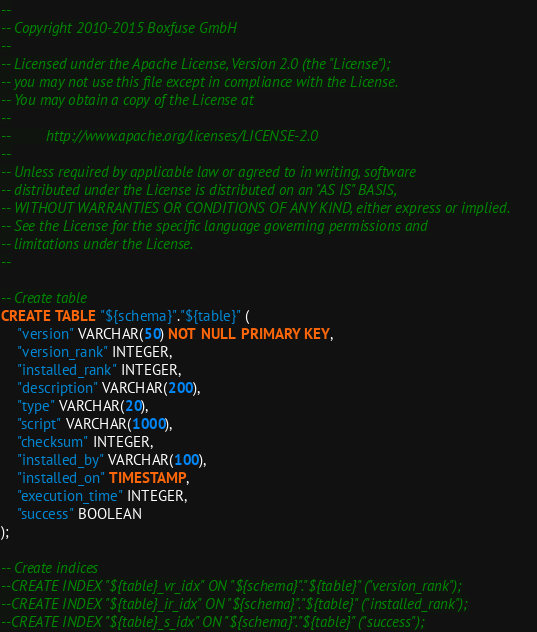<code> <loc_0><loc_0><loc_500><loc_500><_SQL_>--
-- Copyright 2010-2015 Boxfuse GmbH
--
-- Licensed under the Apache License, Version 2.0 (the "License");
-- you may not use this file except in compliance with the License.
-- You may obtain a copy of the License at
--
--         http://www.apache.org/licenses/LICENSE-2.0
--
-- Unless required by applicable law or agreed to in writing, software
-- distributed under the License is distributed on an "AS IS" BASIS,
-- WITHOUT WARRANTIES OR CONDITIONS OF ANY KIND, either express or implied.
-- See the License for the specific language governing permissions and
-- limitations under the License.
--

-- Create table
CREATE TABLE "${schema}"."${table}" (
    "version" VARCHAR(50) NOT NULL PRIMARY KEY,
    "version_rank" INTEGER,
    "installed_rank" INTEGER,
    "description" VARCHAR(200),
    "type" VARCHAR(20),
    "script" VARCHAR(1000),
    "checksum" INTEGER,
    "installed_by" VARCHAR(100),
    "installed_on" TIMESTAMP,
    "execution_time" INTEGER,
    "success" BOOLEAN
);

-- Create indices
--CREATE INDEX "${table}_vr_idx" ON "${schema}"."${table}" ("version_rank");
--CREATE INDEX "${table}_ir_idx" ON "${schema}"."${table}" ("installed_rank");
--CREATE INDEX "${table}_s_idx" ON "${schema}"."${table}" ("success");</code> 